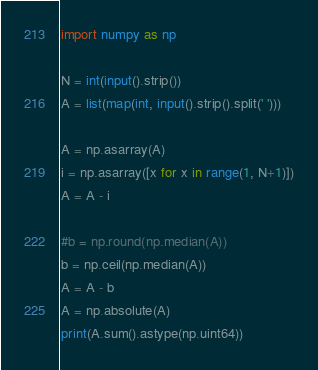<code> <loc_0><loc_0><loc_500><loc_500><_Python_>import numpy as np

N = int(input().strip())
A = list(map(int, input().strip().split(' ')))

A = np.asarray(A)
i = np.asarray([x for x in range(1, N+1)])
A = A - i

#b = np.round(np.median(A))
b = np.ceil(np.median(A))
A = A - b
A = np.absolute(A)
print(A.sum().astype(np.uint64))</code> 